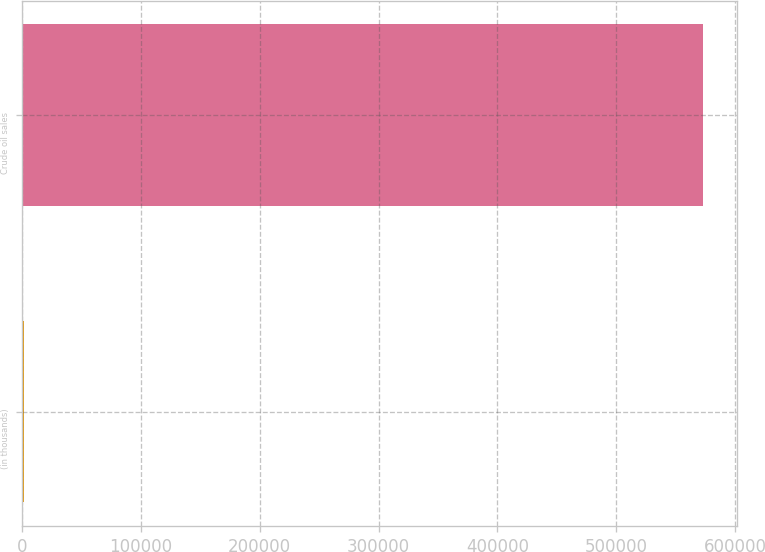<chart> <loc_0><loc_0><loc_500><loc_500><bar_chart><fcel>(in thousands)<fcel>Crude oil sales<nl><fcel>2004<fcel>573393<nl></chart> 